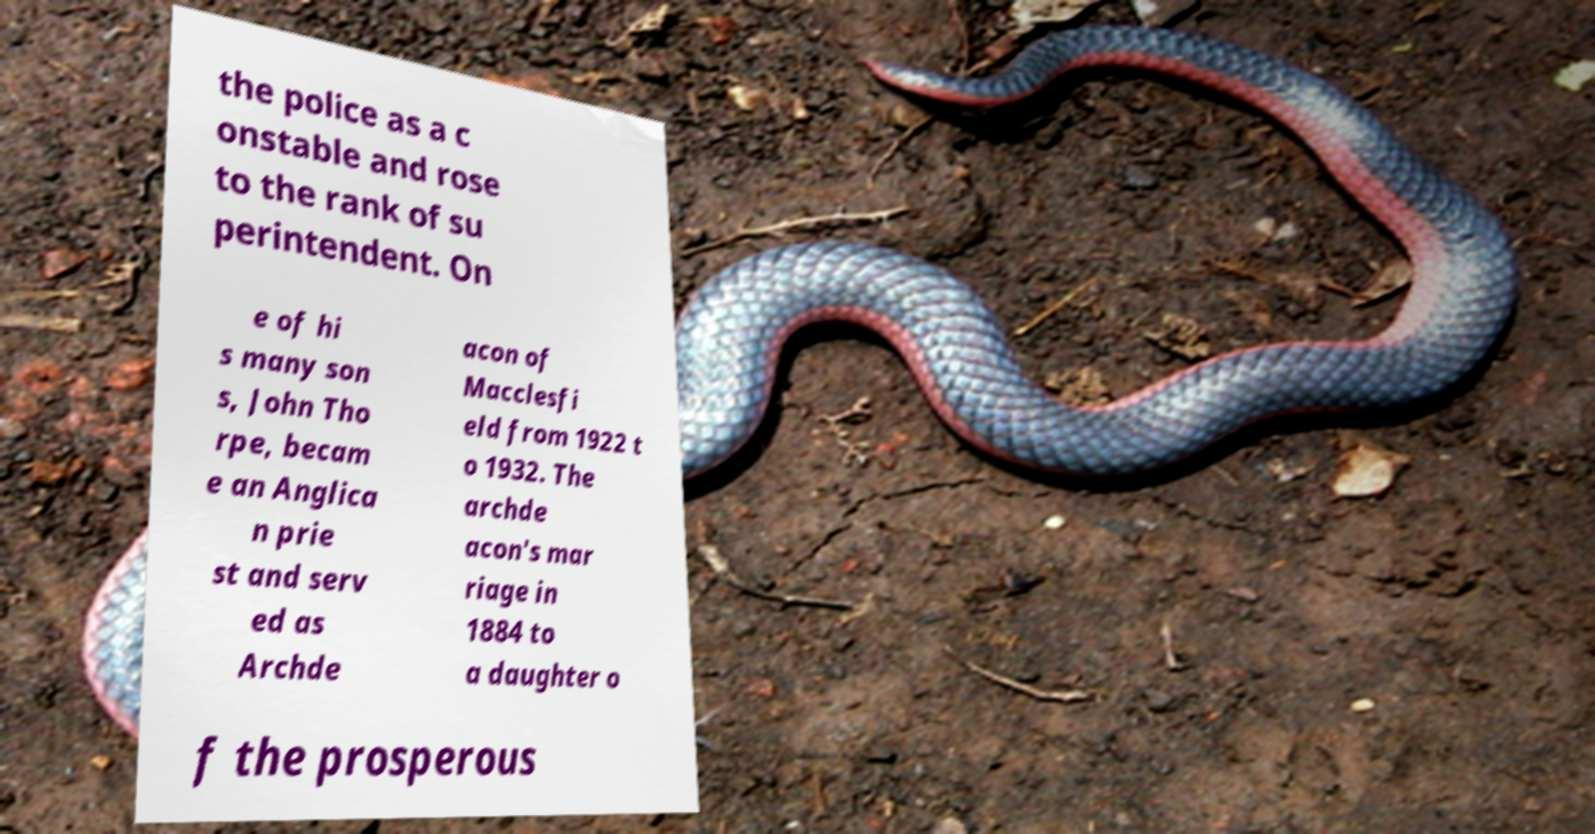For documentation purposes, I need the text within this image transcribed. Could you provide that? the police as a c onstable and rose to the rank of su perintendent. On e of hi s many son s, John Tho rpe, becam e an Anglica n prie st and serv ed as Archde acon of Macclesfi eld from 1922 t o 1932. The archde acon's mar riage in 1884 to a daughter o f the prosperous 